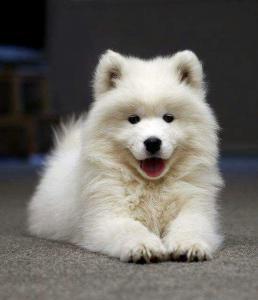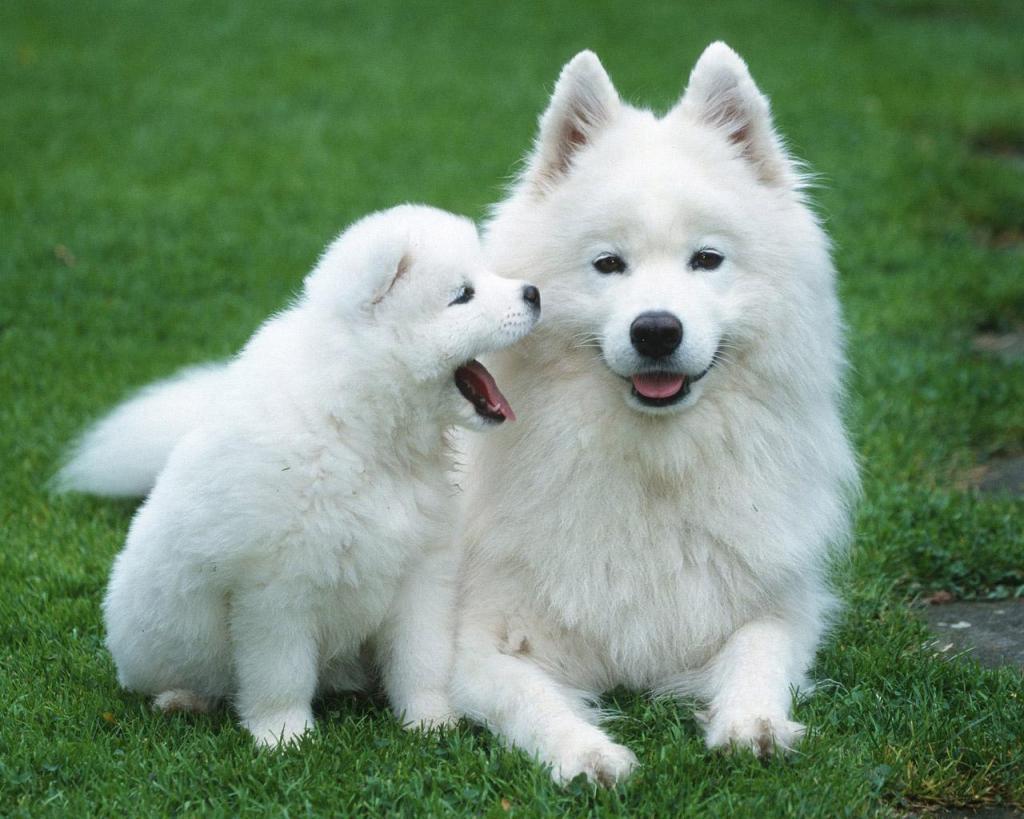The first image is the image on the left, the second image is the image on the right. For the images displayed, is the sentence "The right image contains exactly two white dogs." factually correct? Answer yes or no. Yes. The first image is the image on the left, the second image is the image on the right. Assess this claim about the two images: "One image contains exactly two dogs side-by-side, and the other features one non-standing dog.". Correct or not? Answer yes or no. Yes. 